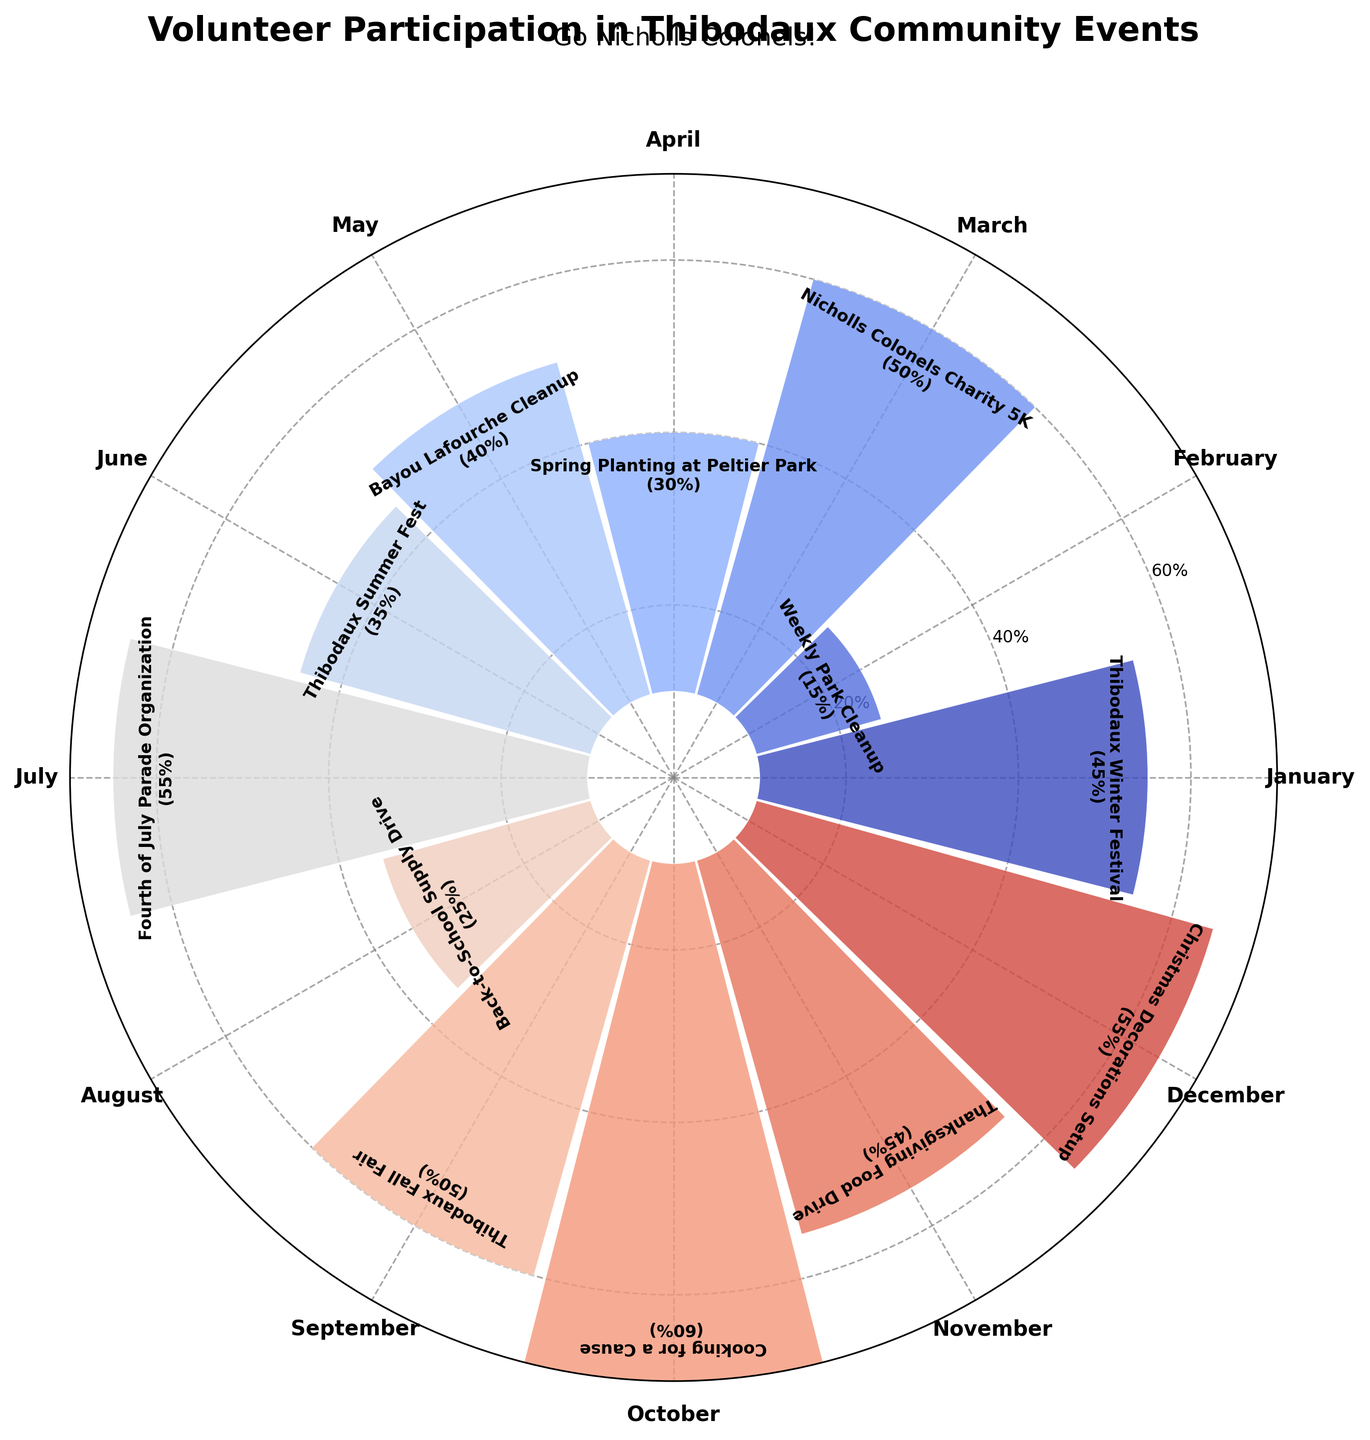What is the title of the polar area chart? The title of any chart is typically located at the top in larger and bold font to summarize the content of the chart. In this case, it is "Volunteer Participation in Thibodaux Community Events," and it is additionally emphasized by a subtitle "Go Nicholls Colonels!"
Answer: Volunteer Participation in Thibodaux Community Events Which event registered the highest volunteer participation rate? To answer this, examine the bars on the polar chart for the one that extends the furthest from the center, representing the highest value. Noting the event and its participation rate label, "Cooking for a Cause" has the highest rate at 60%.
Answer: Cooking for a Cause Which months had two or more events with volunteer participation rates over 50%? Identify the months with events labeled with bars above the 50% mark. Then, check if there are any months with multiple such bars. July, October, and December each have events with participation rates over 50%.
Answer: None What is the average volunteer participation rate across all events? To find the average, sum all the participation rates given in the labels and divide by the number of events. Calculation shows: (45 + 15 + 50 + 30 + 40 + 35 + 55 + 25 + 50 + 60 + 45 + 55) = 505; 505/12 ≈ 42.08.
Answer: Approximately 42.08% Which event had the least volunteer participation rate and in which month did it occur? Look for the shortest bar on the polar chart, which signifies the lowest participation rate. The shortest bar corresponds to the "Weekly Park Cleanup" event in February with a rate of 15%.
Answer: Weekly Park Cleanup in February By how many percentage points does the "Nicholls Colonels Charity 5K" exceed the "Spring Planting at Peltier Park" in volunteer participation rate? Compare the rates by subtracting the smaller from the larger: 50% (Nicholls Colonels Charity 5K) - 30% (Spring Planting at Peltier Park) = 20 percentage points.
Answer: 20 percentage points Which events have a similar volunteer participation rate of 55%? Identify the bars that reach up to the 55% mark to find events with similar participation. From the labels, "Fourth of July Parade Organization" and "Christmas Decorations Setup" both have a participation rate of 55%.
Answer: Fourth of July Parade Organization and Christmas Decorations Setup What is the difference in volunteer participation rates between the "Bayou Lafourche Cleanup" in May and the "Back-to-School Supply Drive" in August? Subtract the participation rate of the August event from that of the May event: 40% (Bayou Lafourche Cleanup) - 25% (Back-to-School Supply Drive) = 15%.
Answer: 15% How many events have volunteer participation rates higher than 50%? Count the number of bars that exceed the 50% mark. The events "Fourth of July Parade Organization," "Cooking for a Cause," and "Christmas Decorations Setup" sum to three events.
Answer: Three What is the range of volunteer participation rates for the events in Thibodaux? The range is calculated by subtracting the minimum participation rate from the maximum rate. Maximum is 60% ("Cooking for a Cause"), and minimum is 15% ("Weekly Park Cleanup"): 60% - 15% = 45%.
Answer: 45% 